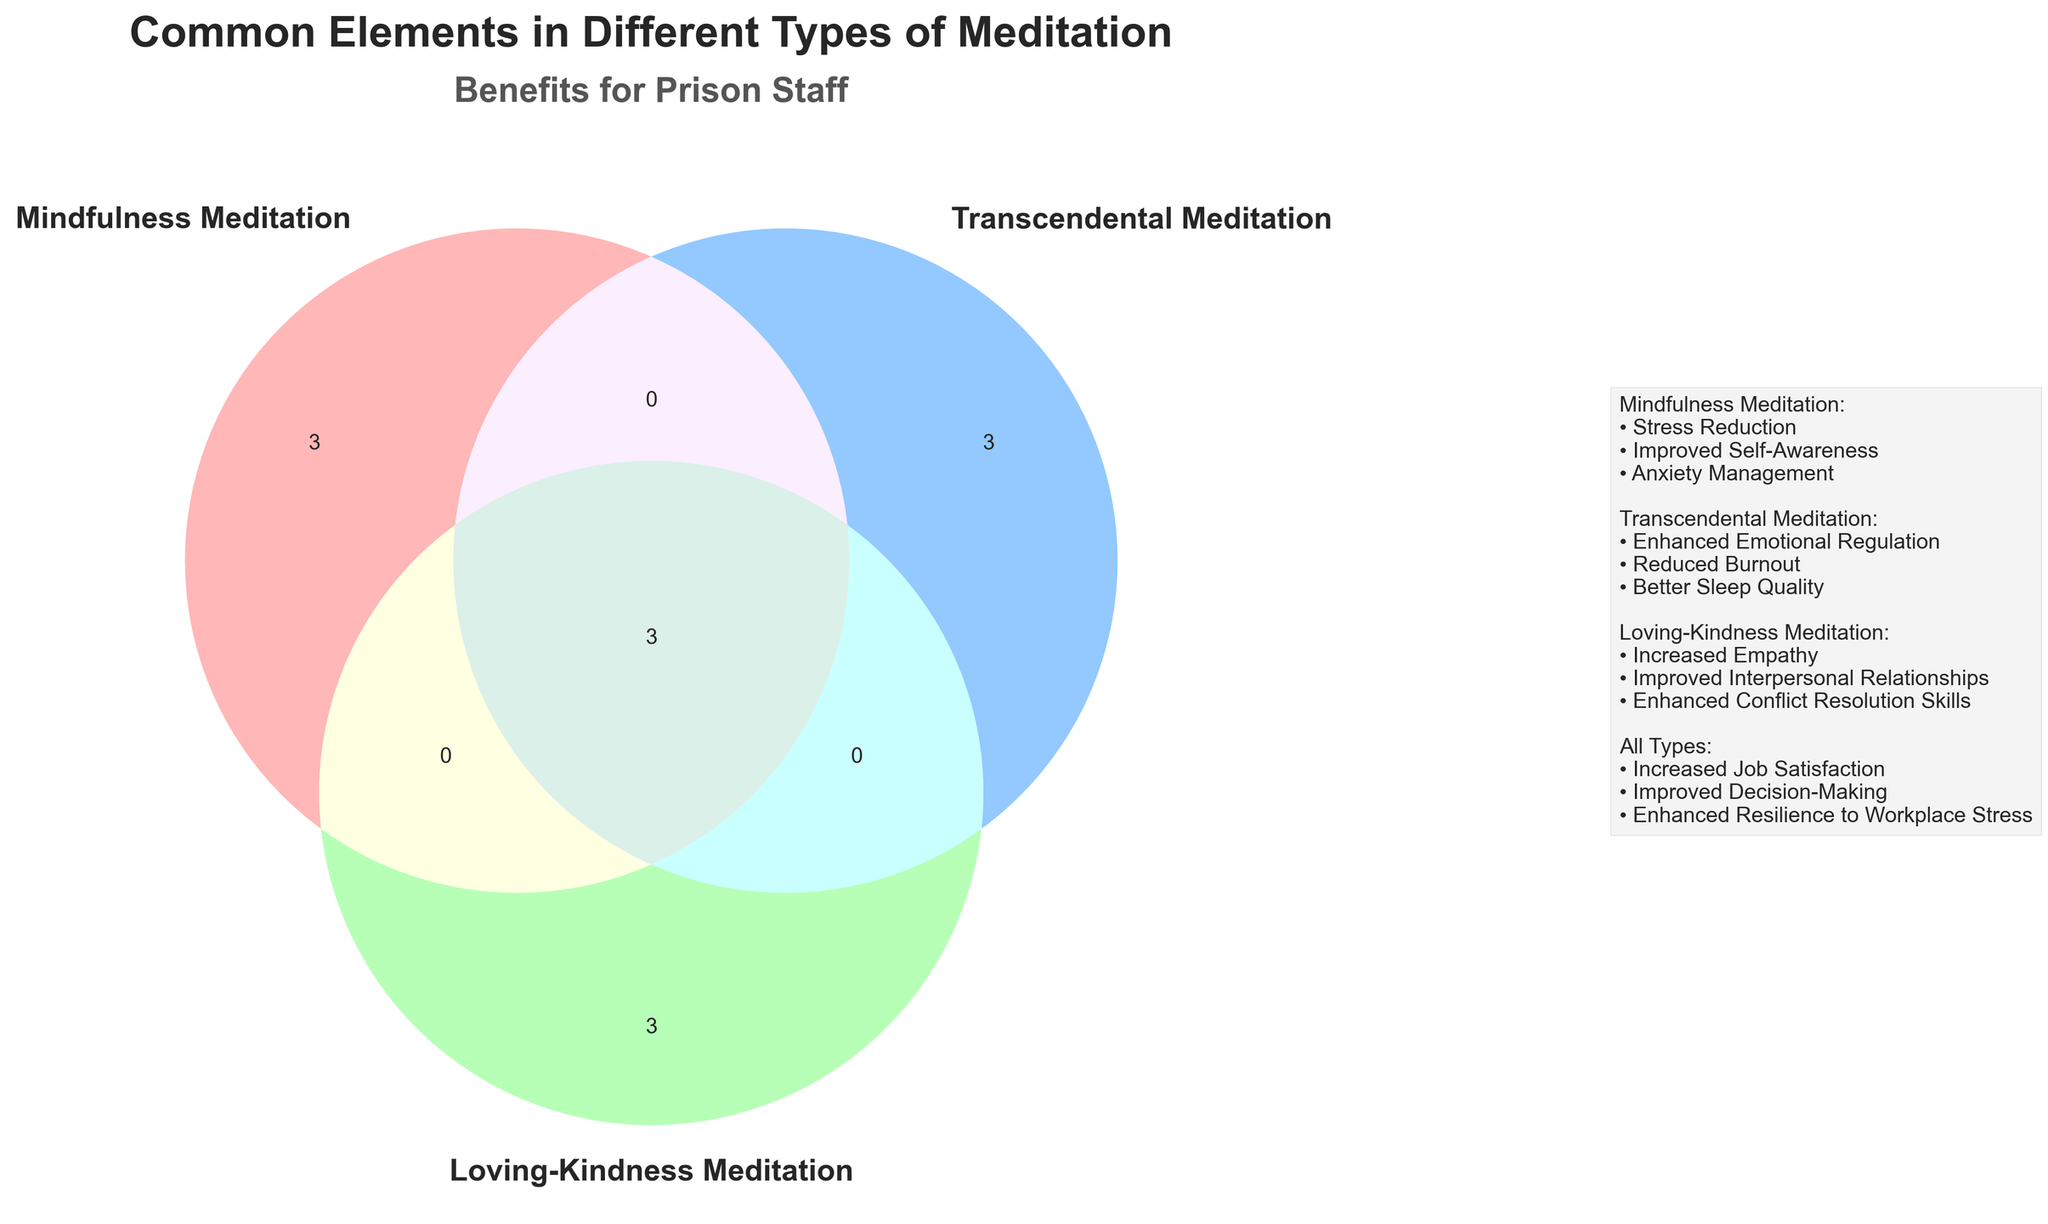What is the title of the Venn diagram? The title is the text at the top of the figure summarizing its content.
Answer: Common Elements in Different Types of Meditation Which types of meditation are included in the Venn diagram? The set labels indicate the types of meditation depicted in the Venn diagram.
Answer: Mindfulness Meditation, Transcendental Meditation, Loving-Kindness Meditation How many elements are shared by all types of meditation? Elements shared by all types are represented in the intersection of all three sets. There are three elements in this intersection.
Answer: 3 What benefits are associated with “Mindfulness Meditation”? Benefits for each type are listed in the legend. For "Mindfulness Meditation," the benefits are listed under its heading.
Answer: Stress Reduction, Improved Self-Awareness, Anxiety Management Which meditation type includes the element "Mantra Repetition"? The element "Mantra Repetition" is specific to one type of meditation depicted in the figure and is listed in the legend under "Transcendental Meditation."
Answer: Transcendental Meditation How many elements are unique to “Loving-Kindness Meditation”? Unique elements are those that do not overlap with other sets. Identify elements present only in the "Loving-Kindness Meditation" set.
Answer: 3 Which meditation type does not share any elements with others? All types share some elements, and their common elements are visible in overlapping regions. No type stands alone without shared elements.
Answer: None What is the common benefit of all meditation types for prison staff? The legend under the benefits for "All Types" lists the common benefits.
Answer: Increased Job Satisfaction, Improved Decision-Making, Enhanced Resilience to Workplace Stress Which type of meditation includes "Focus on Present Moment" and what benefit does it offer? "Focus on Present Moment" appears to belong to one type, as indicated in the legend under "Mindfulness Meditation."
Answer: Mindfulness Meditation; Stress Reduction Compare the number of benefits between "Transcendental Meditation" and "Loving-Kindness Meditation." Count the benefits listed under each type in the legend and compare them. "Transcendental Meditation" has fewer benefits listed compared to "Loving-Kindness Meditation."
Answer: Loving-Kindness Meditation has more benefits 